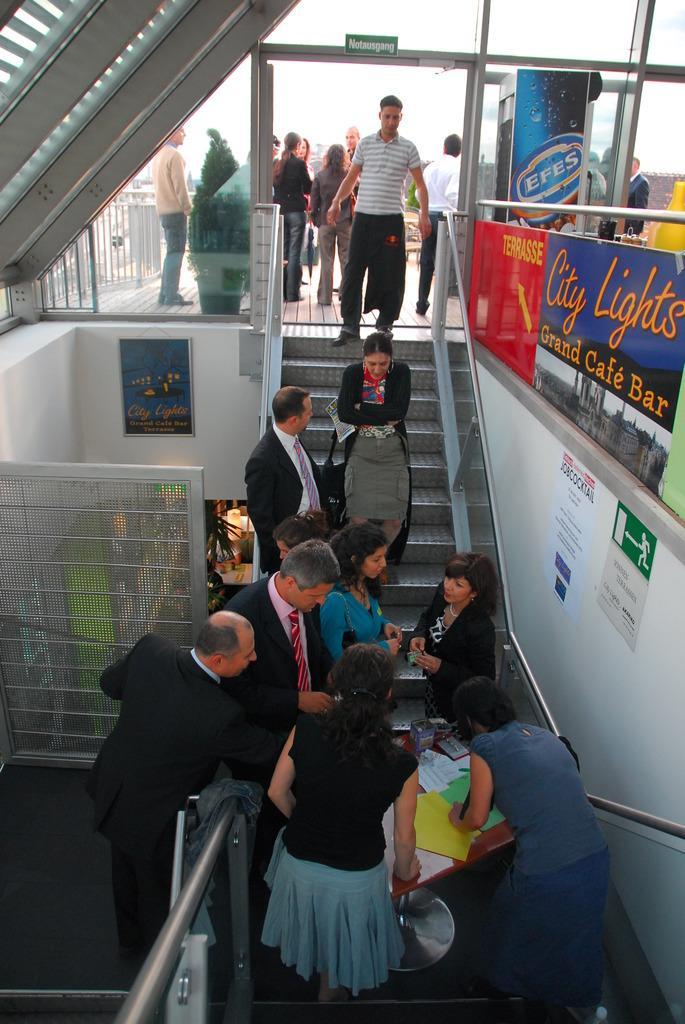Please provide a concise description of this image. In the picture we can see some people standing on the path near the steps and some people on the steps and in the background, we can see some people standing and talking and near to them we can see some railing. 